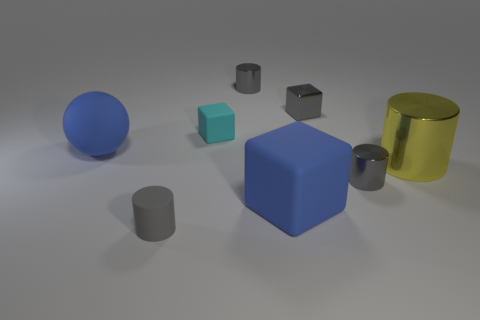Subtract all gray spheres. How many gray cylinders are left? 3 Add 2 large blue rubber cubes. How many objects exist? 10 Subtract all blocks. How many objects are left? 5 Add 6 matte cubes. How many matte cubes are left? 8 Add 5 blue things. How many blue things exist? 7 Subtract 1 cyan blocks. How many objects are left? 7 Subtract all yellow metal balls. Subtract all large matte balls. How many objects are left? 7 